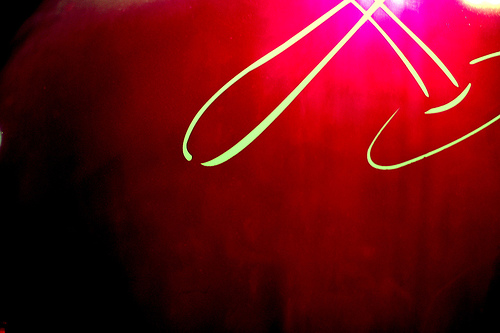<image>
Can you confirm if the light is in the wall? Yes. The light is contained within or inside the wall, showing a containment relationship. 